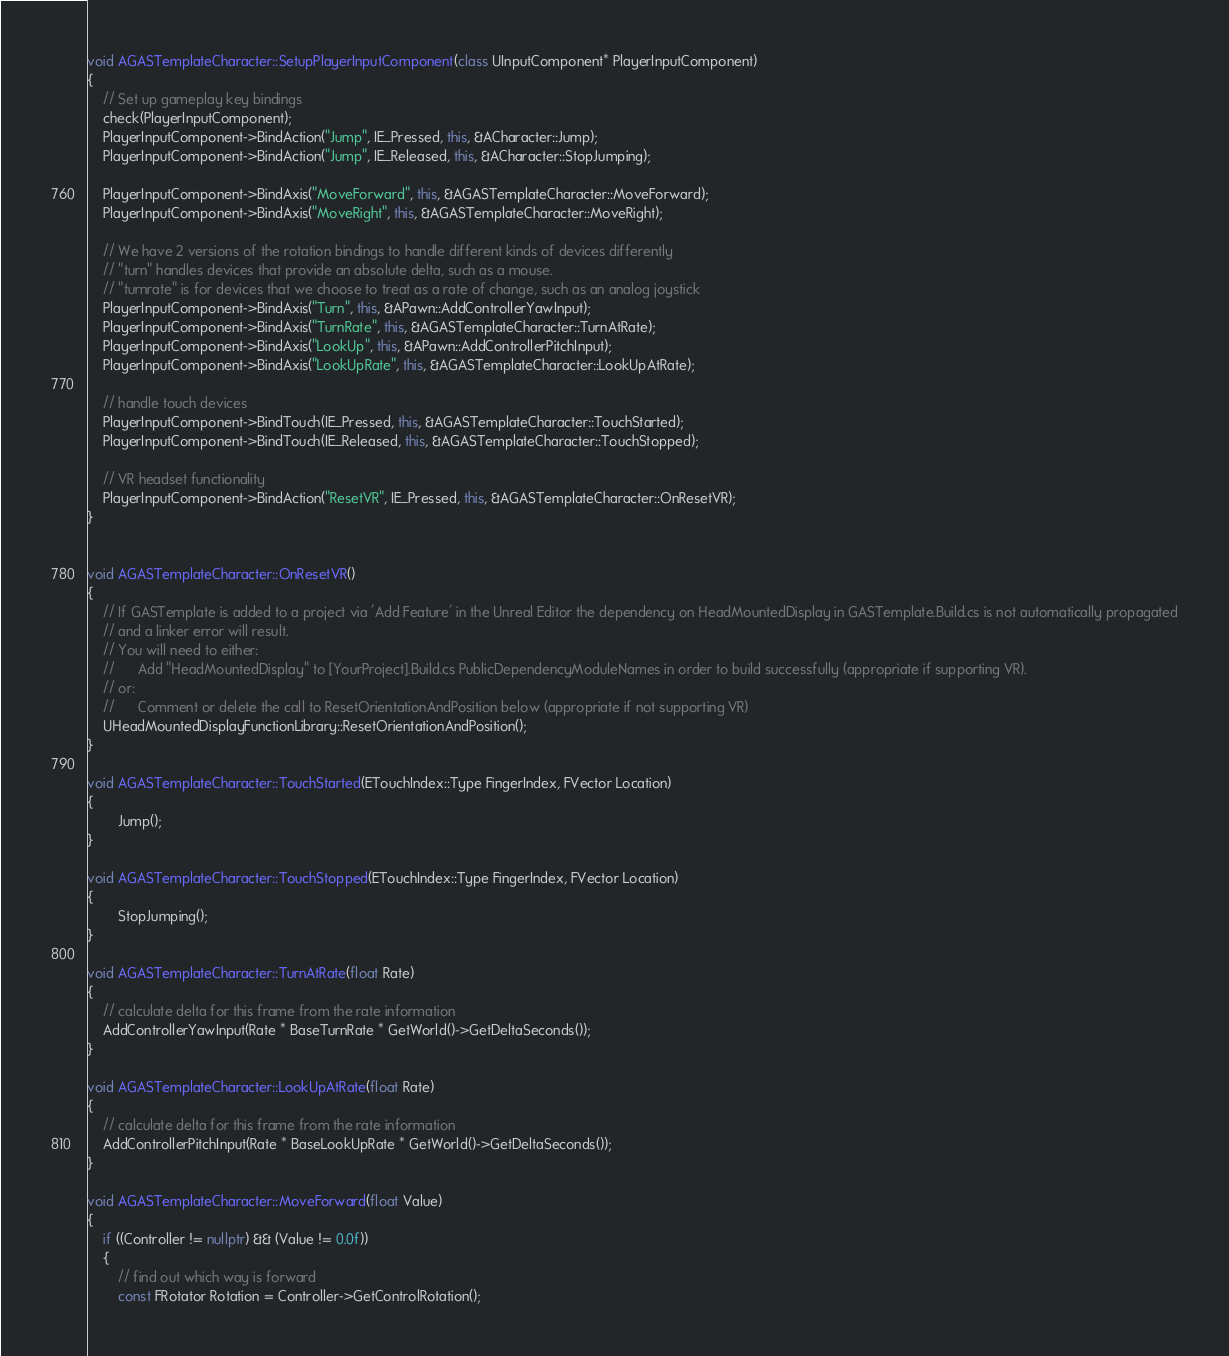Convert code to text. <code><loc_0><loc_0><loc_500><loc_500><_C++_>
void AGASTemplateCharacter::SetupPlayerInputComponent(class UInputComponent* PlayerInputComponent)
{
	// Set up gameplay key bindings
	check(PlayerInputComponent);
	PlayerInputComponent->BindAction("Jump", IE_Pressed, this, &ACharacter::Jump);
	PlayerInputComponent->BindAction("Jump", IE_Released, this, &ACharacter::StopJumping);

	PlayerInputComponent->BindAxis("MoveForward", this, &AGASTemplateCharacter::MoveForward);
	PlayerInputComponent->BindAxis("MoveRight", this, &AGASTemplateCharacter::MoveRight);

	// We have 2 versions of the rotation bindings to handle different kinds of devices differently
	// "turn" handles devices that provide an absolute delta, such as a mouse.
	// "turnrate" is for devices that we choose to treat as a rate of change, such as an analog joystick
	PlayerInputComponent->BindAxis("Turn", this, &APawn::AddControllerYawInput);
	PlayerInputComponent->BindAxis("TurnRate", this, &AGASTemplateCharacter::TurnAtRate);
	PlayerInputComponent->BindAxis("LookUp", this, &APawn::AddControllerPitchInput);
	PlayerInputComponent->BindAxis("LookUpRate", this, &AGASTemplateCharacter::LookUpAtRate);

	// handle touch devices
	PlayerInputComponent->BindTouch(IE_Pressed, this, &AGASTemplateCharacter::TouchStarted);
	PlayerInputComponent->BindTouch(IE_Released, this, &AGASTemplateCharacter::TouchStopped);

	// VR headset functionality
	PlayerInputComponent->BindAction("ResetVR", IE_Pressed, this, &AGASTemplateCharacter::OnResetVR);
}


void AGASTemplateCharacter::OnResetVR()
{
	// If GASTemplate is added to a project via 'Add Feature' in the Unreal Editor the dependency on HeadMountedDisplay in GASTemplate.Build.cs is not automatically propagated
	// and a linker error will result.
	// You will need to either:
	//		Add "HeadMountedDisplay" to [YourProject].Build.cs PublicDependencyModuleNames in order to build successfully (appropriate if supporting VR).
	// or:
	//		Comment or delete the call to ResetOrientationAndPosition below (appropriate if not supporting VR)
	UHeadMountedDisplayFunctionLibrary::ResetOrientationAndPosition();
}

void AGASTemplateCharacter::TouchStarted(ETouchIndex::Type FingerIndex, FVector Location)
{
		Jump();
}

void AGASTemplateCharacter::TouchStopped(ETouchIndex::Type FingerIndex, FVector Location)
{
		StopJumping();
}

void AGASTemplateCharacter::TurnAtRate(float Rate)
{
	// calculate delta for this frame from the rate information
	AddControllerYawInput(Rate * BaseTurnRate * GetWorld()->GetDeltaSeconds());
}

void AGASTemplateCharacter::LookUpAtRate(float Rate)
{
	// calculate delta for this frame from the rate information
	AddControllerPitchInput(Rate * BaseLookUpRate * GetWorld()->GetDeltaSeconds());
}

void AGASTemplateCharacter::MoveForward(float Value)
{
	if ((Controller != nullptr) && (Value != 0.0f))
	{
		// find out which way is forward
		const FRotator Rotation = Controller->GetControlRotation();</code> 